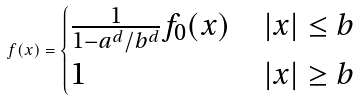Convert formula to latex. <formula><loc_0><loc_0><loc_500><loc_500>f ( x ) = \begin{cases} \frac { 1 } { 1 - a ^ { d } / b ^ { d } } f _ { 0 } ( x ) & | x | \leq b \\ 1 & | x | \geq b \end{cases}</formula> 